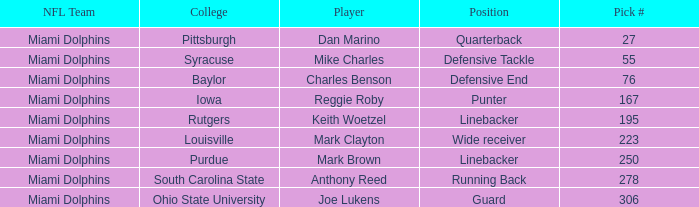Which College has Player Mark Brown and a Pick # greater than 195? Purdue. Help me parse the entirety of this table. {'header': ['NFL Team', 'College', 'Player', 'Position', 'Pick #'], 'rows': [['Miami Dolphins', 'Pittsburgh', 'Dan Marino', 'Quarterback', '27'], ['Miami Dolphins', 'Syracuse', 'Mike Charles', 'Defensive Tackle', '55'], ['Miami Dolphins', 'Baylor', 'Charles Benson', 'Defensive End', '76'], ['Miami Dolphins', 'Iowa', 'Reggie Roby', 'Punter', '167'], ['Miami Dolphins', 'Rutgers', 'Keith Woetzel', 'Linebacker', '195'], ['Miami Dolphins', 'Louisville', 'Mark Clayton', 'Wide receiver', '223'], ['Miami Dolphins', 'Purdue', 'Mark Brown', 'Linebacker', '250'], ['Miami Dolphins', 'South Carolina State', 'Anthony Reed', 'Running Back', '278'], ['Miami Dolphins', 'Ohio State University', 'Joe Lukens', 'Guard', '306']]} 